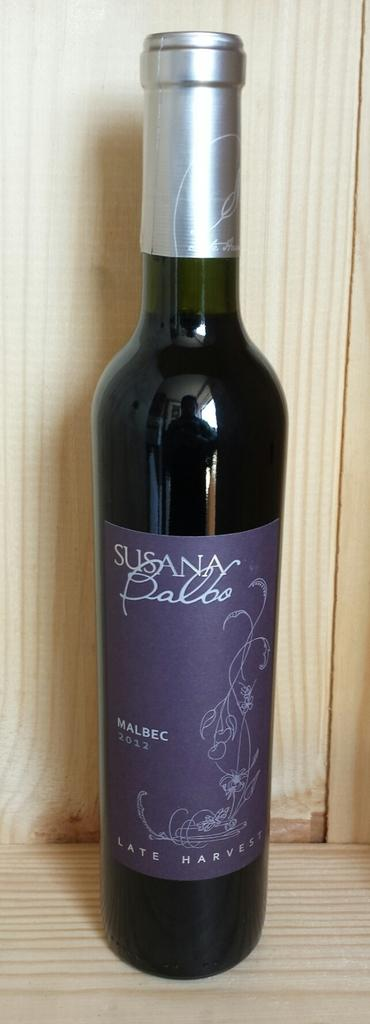<image>
Present a compact description of the photo's key features. Unopened very thin wine bottle of Susana Balboa 2012 Malbec, Late Harvest. 